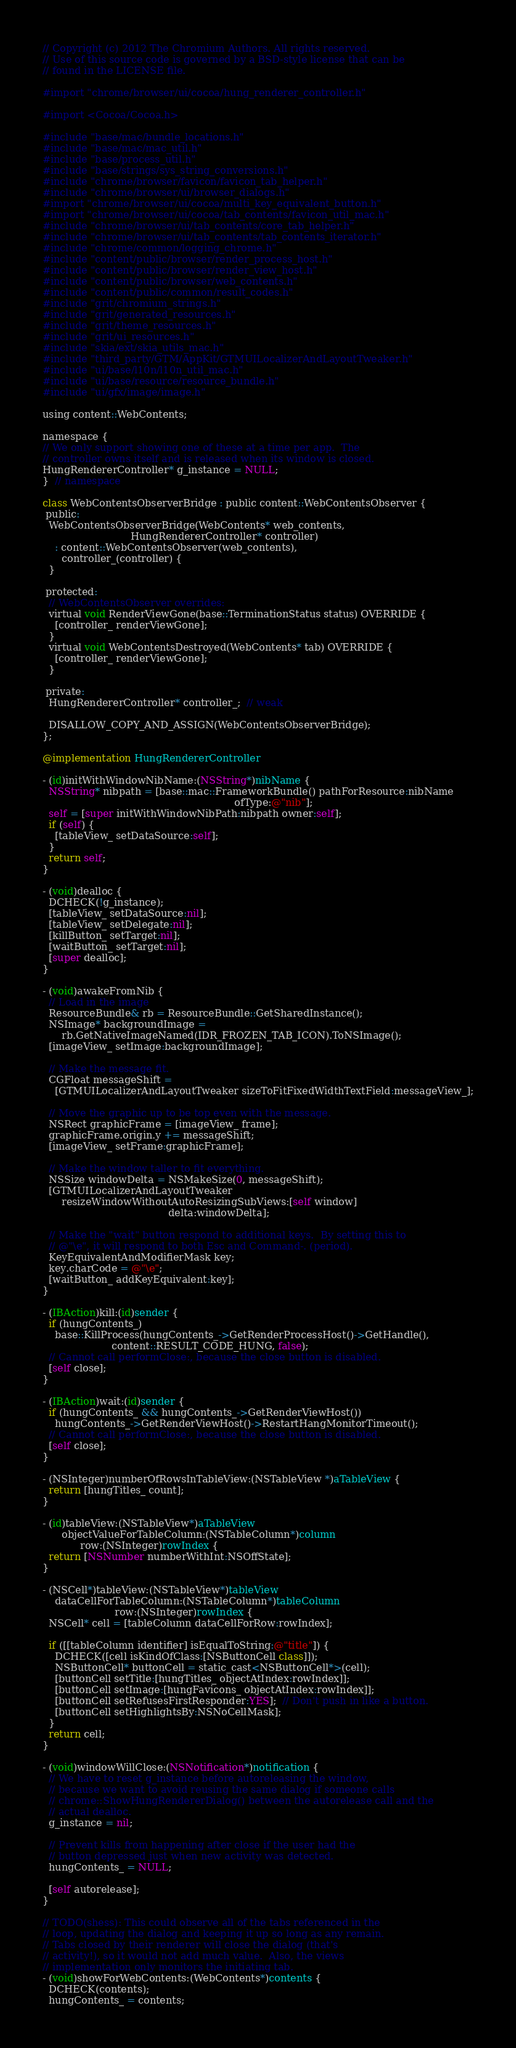Convert code to text. <code><loc_0><loc_0><loc_500><loc_500><_ObjectiveC_>// Copyright (c) 2012 The Chromium Authors. All rights reserved.
// Use of this source code is governed by a BSD-style license that can be
// found in the LICENSE file.

#import "chrome/browser/ui/cocoa/hung_renderer_controller.h"

#import <Cocoa/Cocoa.h>

#include "base/mac/bundle_locations.h"
#include "base/mac/mac_util.h"
#include "base/process_util.h"
#include "base/strings/sys_string_conversions.h"
#include "chrome/browser/favicon/favicon_tab_helper.h"
#include "chrome/browser/ui/browser_dialogs.h"
#import "chrome/browser/ui/cocoa/multi_key_equivalent_button.h"
#import "chrome/browser/ui/cocoa/tab_contents/favicon_util_mac.h"
#include "chrome/browser/ui/tab_contents/core_tab_helper.h"
#include "chrome/browser/ui/tab_contents/tab_contents_iterator.h"
#include "chrome/common/logging_chrome.h"
#include "content/public/browser/render_process_host.h"
#include "content/public/browser/render_view_host.h"
#include "content/public/browser/web_contents.h"
#include "content/public/common/result_codes.h"
#include "grit/chromium_strings.h"
#include "grit/generated_resources.h"
#include "grit/theme_resources.h"
#include "grit/ui_resources.h"
#include "skia/ext/skia_utils_mac.h"
#include "third_party/GTM/AppKit/GTMUILocalizerAndLayoutTweaker.h"
#include "ui/base/l10n/l10n_util_mac.h"
#include "ui/base/resource/resource_bundle.h"
#include "ui/gfx/image/image.h"

using content::WebContents;

namespace {
// We only support showing one of these at a time per app.  The
// controller owns itself and is released when its window is closed.
HungRendererController* g_instance = NULL;
}  // namespace

class WebContentsObserverBridge : public content::WebContentsObserver {
 public:
  WebContentsObserverBridge(WebContents* web_contents,
                            HungRendererController* controller)
    : content::WebContentsObserver(web_contents),
      controller_(controller) {
  }

 protected:
  // WebContentsObserver overrides:
  virtual void RenderViewGone(base::TerminationStatus status) OVERRIDE {
    [controller_ renderViewGone];
  }
  virtual void WebContentsDestroyed(WebContents* tab) OVERRIDE {
    [controller_ renderViewGone];
  }

 private:
  HungRendererController* controller_;  // weak

  DISALLOW_COPY_AND_ASSIGN(WebContentsObserverBridge);
};

@implementation HungRendererController

- (id)initWithWindowNibName:(NSString*)nibName {
  NSString* nibpath = [base::mac::FrameworkBundle() pathForResource:nibName
                                                             ofType:@"nib"];
  self = [super initWithWindowNibPath:nibpath owner:self];
  if (self) {
    [tableView_ setDataSource:self];
  }
  return self;
}

- (void)dealloc {
  DCHECK(!g_instance);
  [tableView_ setDataSource:nil];
  [tableView_ setDelegate:nil];
  [killButton_ setTarget:nil];
  [waitButton_ setTarget:nil];
  [super dealloc];
}

- (void)awakeFromNib {
  // Load in the image
  ResourceBundle& rb = ResourceBundle::GetSharedInstance();
  NSImage* backgroundImage =
      rb.GetNativeImageNamed(IDR_FROZEN_TAB_ICON).ToNSImage();
  [imageView_ setImage:backgroundImage];

  // Make the message fit.
  CGFloat messageShift =
    [GTMUILocalizerAndLayoutTweaker sizeToFitFixedWidthTextField:messageView_];

  // Move the graphic up to be top even with the message.
  NSRect graphicFrame = [imageView_ frame];
  graphicFrame.origin.y += messageShift;
  [imageView_ setFrame:graphicFrame];

  // Make the window taller to fit everything.
  NSSize windowDelta = NSMakeSize(0, messageShift);
  [GTMUILocalizerAndLayoutTweaker
      resizeWindowWithoutAutoResizingSubViews:[self window]
                                        delta:windowDelta];

  // Make the "wait" button respond to additional keys.  By setting this to
  // @"\e", it will respond to both Esc and Command-. (period).
  KeyEquivalentAndModifierMask key;
  key.charCode = @"\e";
  [waitButton_ addKeyEquivalent:key];
}

- (IBAction)kill:(id)sender {
  if (hungContents_)
    base::KillProcess(hungContents_->GetRenderProcessHost()->GetHandle(),
                      content::RESULT_CODE_HUNG, false);
  // Cannot call performClose:, because the close button is disabled.
  [self close];
}

- (IBAction)wait:(id)sender {
  if (hungContents_ && hungContents_->GetRenderViewHost())
    hungContents_->GetRenderViewHost()->RestartHangMonitorTimeout();
  // Cannot call performClose:, because the close button is disabled.
  [self close];
}

- (NSInteger)numberOfRowsInTableView:(NSTableView *)aTableView {
  return [hungTitles_ count];
}

- (id)tableView:(NSTableView*)aTableView
      objectValueForTableColumn:(NSTableColumn*)column
            row:(NSInteger)rowIndex {
  return [NSNumber numberWithInt:NSOffState];
}

- (NSCell*)tableView:(NSTableView*)tableView
    dataCellForTableColumn:(NSTableColumn*)tableColumn
                       row:(NSInteger)rowIndex {
  NSCell* cell = [tableColumn dataCellForRow:rowIndex];

  if ([[tableColumn identifier] isEqualToString:@"title"]) {
    DCHECK([cell isKindOfClass:[NSButtonCell class]]);
    NSButtonCell* buttonCell = static_cast<NSButtonCell*>(cell);
    [buttonCell setTitle:[hungTitles_ objectAtIndex:rowIndex]];
    [buttonCell setImage:[hungFavicons_ objectAtIndex:rowIndex]];
    [buttonCell setRefusesFirstResponder:YES];  // Don't push in like a button.
    [buttonCell setHighlightsBy:NSNoCellMask];
  }
  return cell;
}

- (void)windowWillClose:(NSNotification*)notification {
  // We have to reset g_instance before autoreleasing the window,
  // because we want to avoid reusing the same dialog if someone calls
  // chrome::ShowHungRendererDialog() between the autorelease call and the
  // actual dealloc.
  g_instance = nil;

  // Prevent kills from happening after close if the user had the
  // button depressed just when new activity was detected.
  hungContents_ = NULL;

  [self autorelease];
}

// TODO(shess): This could observe all of the tabs referenced in the
// loop, updating the dialog and keeping it up so long as any remain.
// Tabs closed by their renderer will close the dialog (that's
// activity!), so it would not add much value.  Also, the views
// implementation only monitors the initiating tab.
- (void)showForWebContents:(WebContents*)contents {
  DCHECK(contents);
  hungContents_ = contents;</code> 